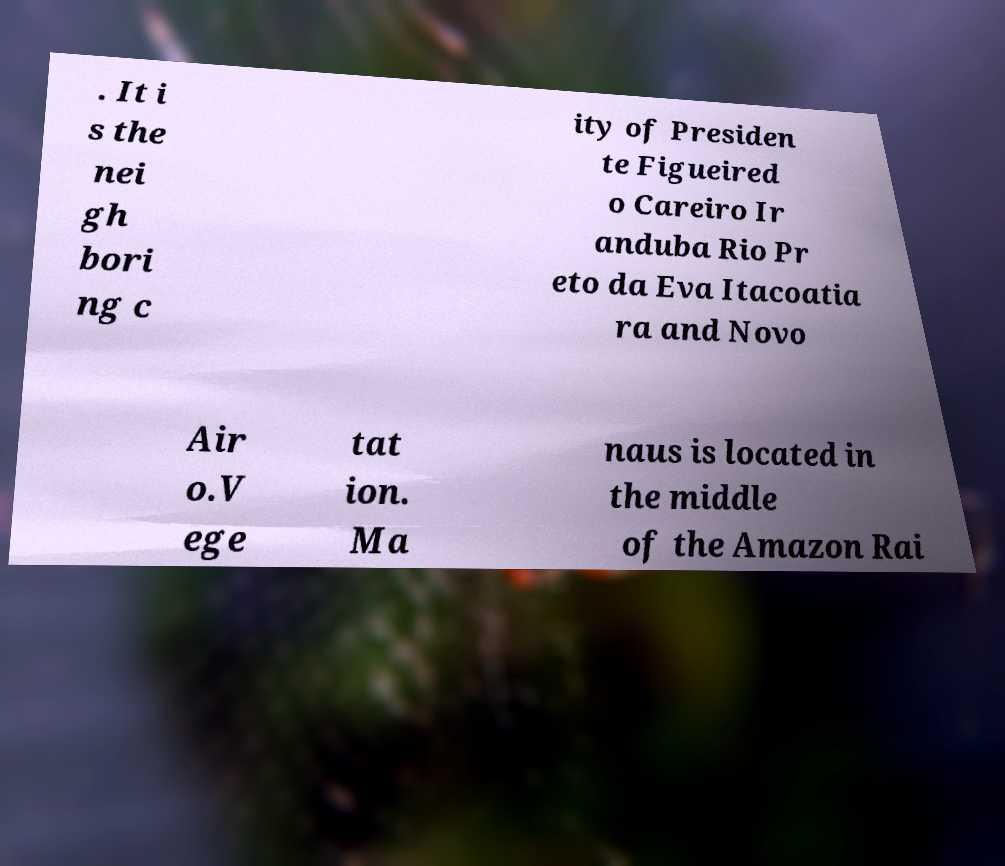Could you assist in decoding the text presented in this image and type it out clearly? . It i s the nei gh bori ng c ity of Presiden te Figueired o Careiro Ir anduba Rio Pr eto da Eva Itacoatia ra and Novo Air o.V ege tat ion. Ma naus is located in the middle of the Amazon Rai 